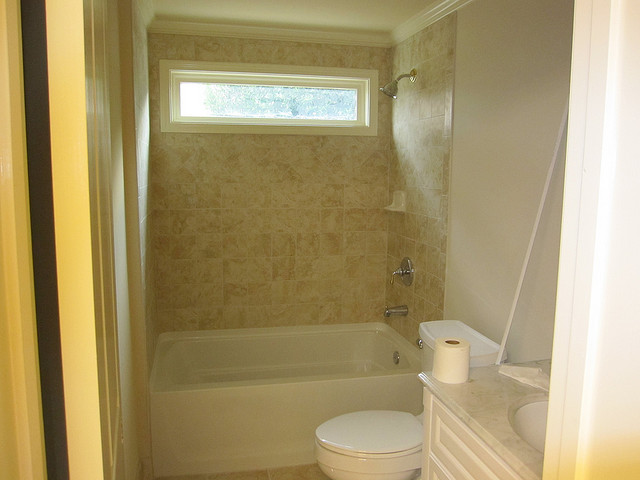What items can you identify in the bathroom that indicate it's in use? The bathroom appears to be in use as evidenced by the presence of a roll of toilet paper placed beside the toilet and a bath towel hanging on the tub's side. The personal hygiene items, however, are not visible, which might suggest that the space is kept tidy or not currently occupied. 